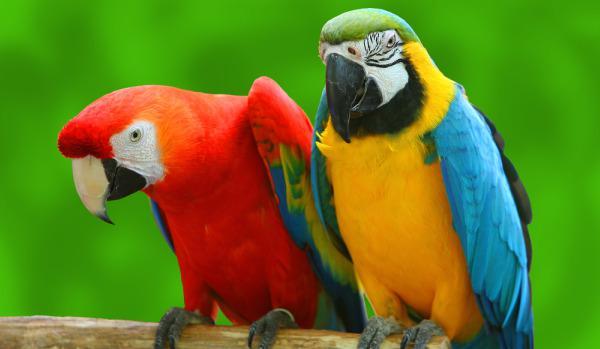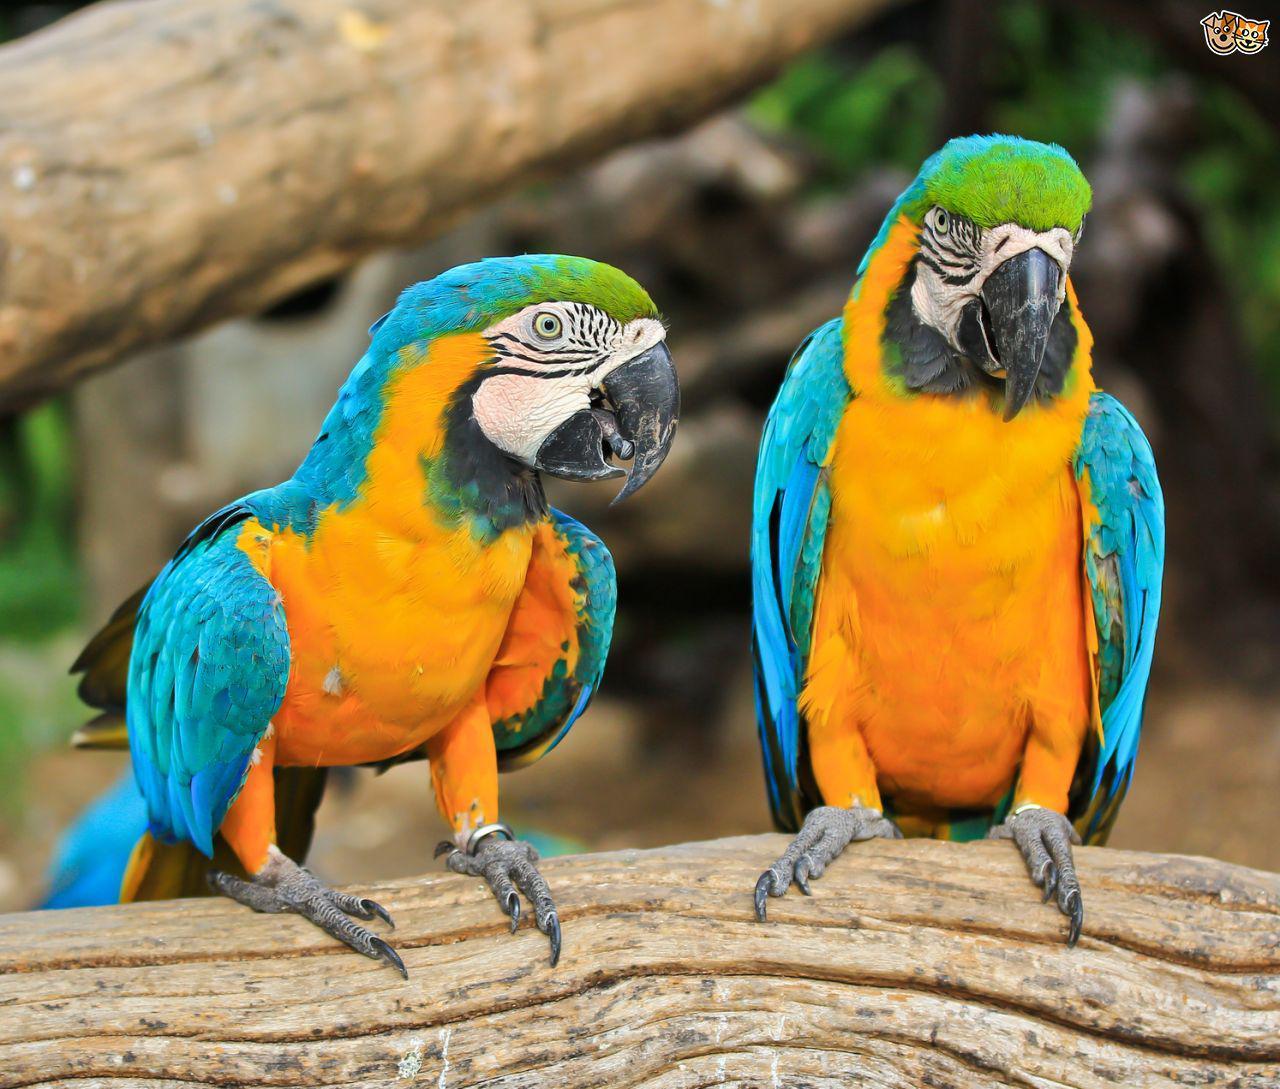The first image is the image on the left, the second image is the image on the right. Considering the images on both sides, is "All birds shown have blue and yellow coloring, and at least one image has green fanning fronds in the background." valid? Answer yes or no. No. The first image is the image on the left, the second image is the image on the right. Given the left and right images, does the statement "There are at least two parrots in the right image." hold true? Answer yes or no. Yes. 